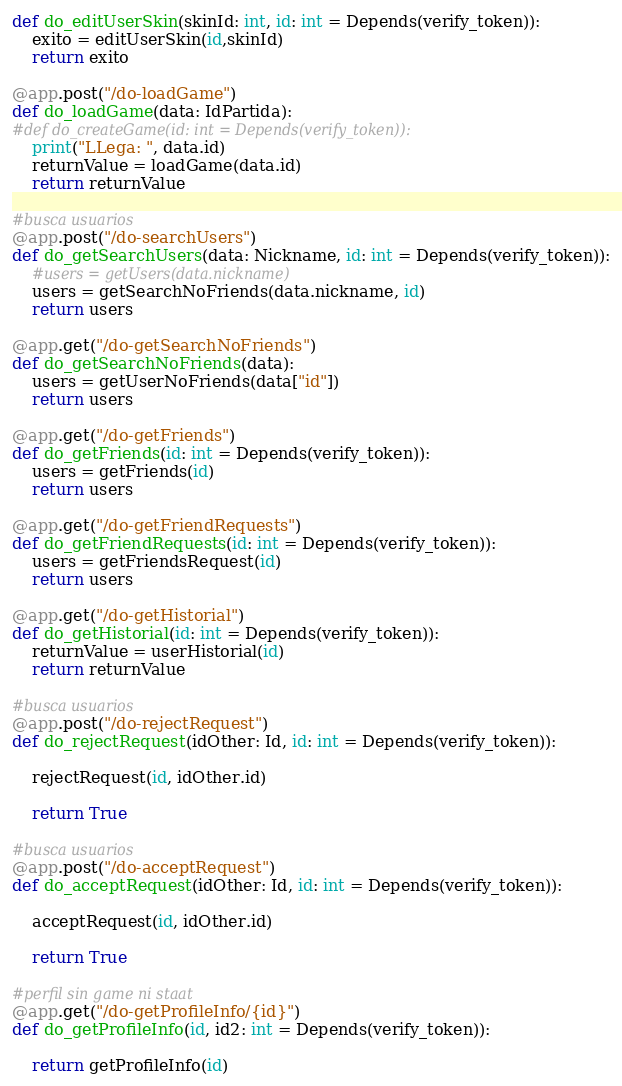Convert code to text. <code><loc_0><loc_0><loc_500><loc_500><_Python_>def do_editUserSkin(skinId: int, id: int = Depends(verify_token)):
    exito = editUserSkin(id,skinId)
    return exito
    
@app.post("/do-loadGame")
def do_loadGame(data: IdPartida):
#def do_createGame(id: int = Depends(verify_token)):
    print("LLega: ", data.id)
    returnValue = loadGame(data.id)
    return returnValue

#busca usuarios
@app.post("/do-searchUsers")
def do_getSearchUsers(data: Nickname, id: int = Depends(verify_token)):
    #users = getUsers(data.nickname)
    users = getSearchNoFriends(data.nickname, id)
    return users

@app.get("/do-getSearchNoFriends")
def do_getSearchNoFriends(data):
    users = getUserNoFriends(data["id"])
    return users

@app.get("/do-getFriends")
def do_getFriends(id: int = Depends(verify_token)):
    users = getFriends(id)
    return users

@app.get("/do-getFriendRequests")
def do_getFriendRequests(id: int = Depends(verify_token)):
    users = getFriendsRequest(id)
    return users

@app.get("/do-getHistorial")
def do_getHistorial(id: int = Depends(verify_token)):
    returnValue = userHistorial(id)
    return returnValue

#busca usuarios
@app.post("/do-rejectRequest")
def do_rejectRequest(idOther: Id, id: int = Depends(verify_token)):

    rejectRequest(id, idOther.id)
    
    return True

#busca usuarios
@app.post("/do-acceptRequest")
def do_acceptRequest(idOther: Id, id: int = Depends(verify_token)):
    
    acceptRequest(id, idOther.id)
    
    return True

#perfil sin game ni staat
@app.get("/do-getProfileInfo/{id}")
def do_getProfileInfo(id, id2: int = Depends(verify_token)):
    
    return getProfileInfo(id)




</code> 